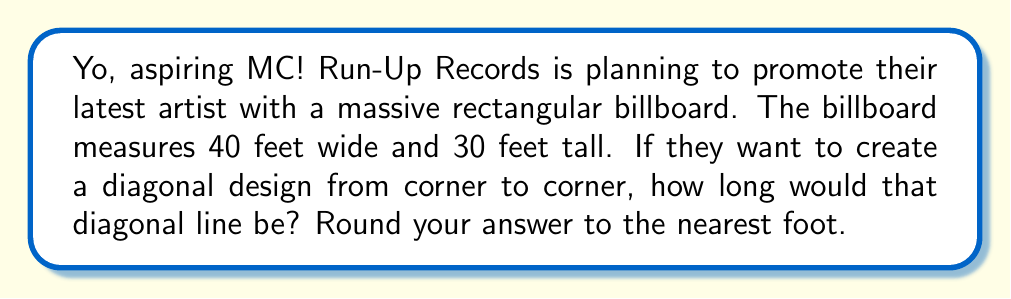Could you help me with this problem? Let's break this down, step by step:

1) We're dealing with a rectangular billboard here. The diagonal forms a right triangle with the width and height of the billboard.

2) We can use the Pythagorean theorem to solve this. The theorem states that in a right triangle:

   $a^2 + b^2 = c^2$

   Where $c$ is the length of the hypotenuse (our diagonal), and $a$ and $b$ are the lengths of the other two sides.

3) Let's plug in our values:
   $a = 40$ (width)
   $b = 30$ (height)

4) Now we can set up our equation:

   $40^2 + 30^2 = c^2$

5) Let's solve it:
   
   $1600 + 900 = c^2$
   $2500 = c^2$

6) To find $c$, we need to take the square root of both sides:

   $c = \sqrt{2500}$

7) Simplify:
   $c = 50$

8) The question asks to round to the nearest foot, but 50 is already a whole number, so no rounding is necessary.

[asy]
import geometry;

size(200);
pair A=(0,0), B=(40,0), C=(40,30), D=(0,30);
draw(A--B--C--D--cycle);
draw(A--C,red);
label("40'",B,(0,-2));
label("30'",C,(2,0));
label("?",A--C,(1,1),red);
[/asy]
Answer: 50 feet 